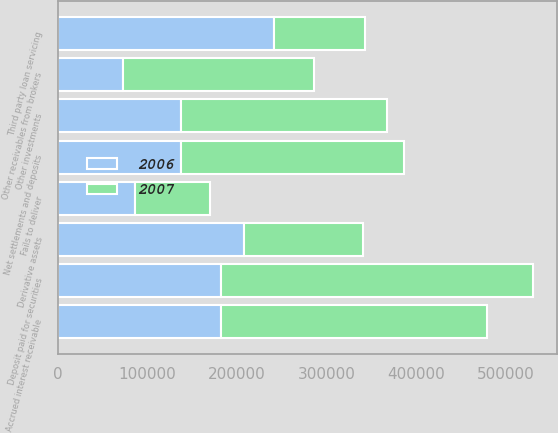Convert chart to OTSL. <chart><loc_0><loc_0><loc_500><loc_500><stacked_bar_chart><ecel><fcel>Deposit paid for securities<fcel>Accrued interest receivable<fcel>Net settlements and deposits<fcel>Other investments<fcel>Other receivables from brokers<fcel>Derivative assets<fcel>Third party loan servicing<fcel>Fails to deliver<nl><fcel>2007<fcel>348337<fcel>296903<fcel>249065<fcel>229207<fcel>213541<fcel>133106<fcel>101571<fcel>84015<nl><fcel>2006<fcel>182265<fcel>182265<fcel>137571<fcel>138006<fcel>72596<fcel>208136<fcel>241511<fcel>86517<nl></chart> 